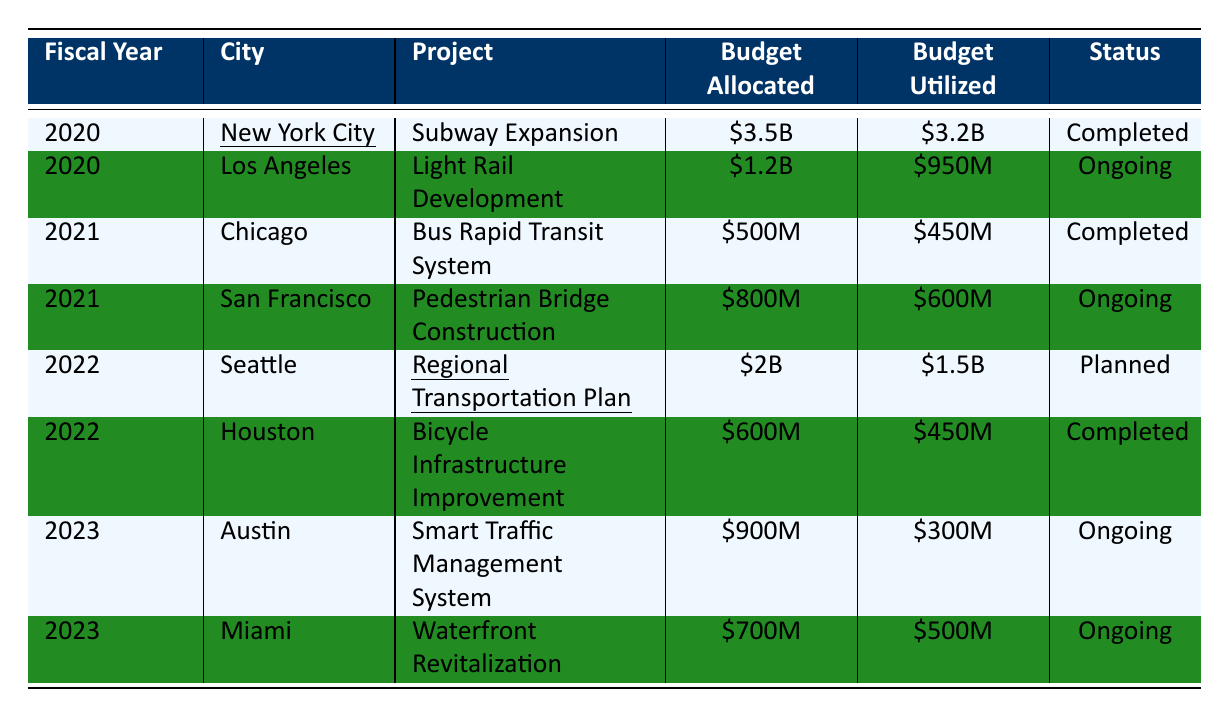What is the total budget allocated for urban infrastructure projects in 2020? There are two projects listed for 2020: New York City's Subway Expansion with a budget of $3.5 billion and Los Angeles's Light Rail Development with a budget of $1.2 billion. Adding these together: $3.5B + $1.2B = $4.7B.
Answer: $4.7 billion Which city's project had the highest budget utilized in 2022? In 2022, Seattle's Regional Transportation Plan had a budget utilized of $1.5 billion, while Houston's Bicycle Infrastructure Improvement had $450 million utilized. Hence, Seattle had the highest utilized budget.
Answer: Seattle Is the Pedestrian Bridge Construction project in San Francisco completed? The status of the Pedestrian Bridge Construction project is listed as "Ongoing," so it is not completed.
Answer: No What is the average budget allocated for all projects listed in 2021? The projects in 2021 are: Chicago's Bus Rapid Transit System ($500M) and San Francisco's Pedestrian Bridge Construction ($800M). The total budget for both projects is $500M + $800M = $1.3B. There are 2 projects, so the average is $1.3B / 2 = $650M.
Answer: $650 million How much budget was utilized for the ongoing projects in 2023? The ongoing projects in 2023 are Austin's Smart Traffic Management System with a budget utilized of $300 million and Miami's Waterfront Revitalization with $500 million utilized. Adding these: $300M + $500M = $800M.
Answer: $800 million Which project had the smallest budget allocated and what is its status? The project with the smallest budget allocated is Chicago's Bus Rapid Transit System at $500 million, and its status is "Completed."
Answer: $500 million, Completed What percentage of the budget was utilized for the Subway Expansion project in New York City? The budget allocated for the Subway Expansion is $3.5 billion, and the budget utilized is $3.2 billion. To find the percentage, we use the formula (utilized / allocated) * 100, which gives ($3.2B / $3.5B) * 100 = 91.43%.
Answer: 91.43% Which city has the most ongoing projects listed and what are they? In 2023, both Austin and Miami have ongoing projects, making a total of two ongoing projects listed in that year. No other cities have ongoing projects in the other years, so they are the cities with the most ongoing projects. The projects are: Austin's Smart Traffic Management System and Miami's Waterfront Revitalization.
Answer: Austin and Miami; Smart Traffic Management System, Waterfront Revitalization 